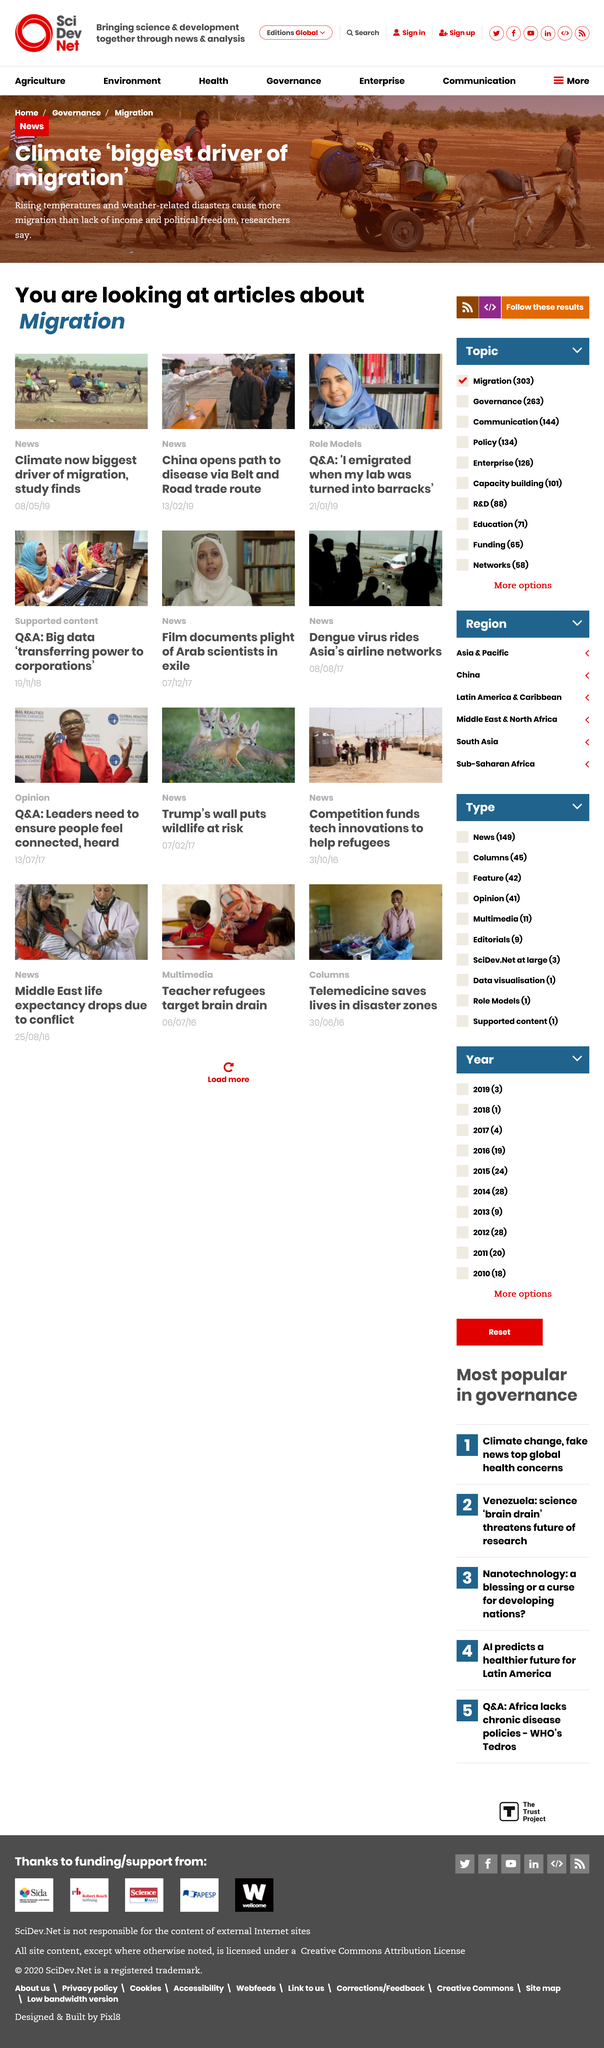Indicate a few pertinent items in this graphic. As of my knowledge cutoff date, there were two articles classified as 'News'. However, it is unknown how many articles classified as 'News' are shown in the feed after my knowledge cutoff date. The headscarf in the photo accompanying the article on Role Models is blue. The biggest driver of migration is now considered to be the climate, according to sources. 